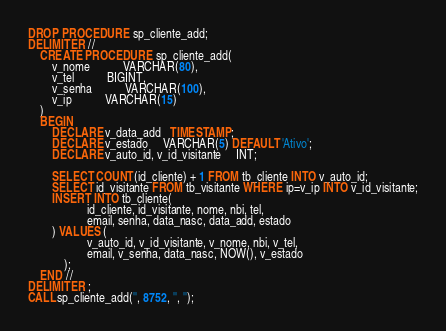<code> <loc_0><loc_0><loc_500><loc_500><_SQL_>DROP PROCEDURE sp_cliente_add;
DELIMITER //
	CREATE PROCEDURE sp_cliente_add(
		v_nome 		   VARCHAR(80),
		v_tel 		   BIGINT,
		v_senha	       VARCHAR(100),
		v_ip 		   VARCHAR(15)
    )
    BEGIN
        DECLARE v_data_add   TIMESTAMP;
		DECLARE v_estado     VARCHAR(5) DEFAULT 'Ativo';
        DECLARE v_auto_id, v_id_visitante	 INT;

        SELECT COUNT(id_cliente) + 1 FROM tb_cliente INTO v_auto_id;
        SELECT id_visitante FROM tb_visitante WHERE ip=v_ip INTO v_id_visitante;
		INSERT INTO tb_cliente(
					id_cliente, id_visitante, nome, nbi, tel, 
					email, senha, data_nasc, data_add, estado
		) VALUES (
					v_auto_id, v_id_visitante, v_nome, nbi, v_tel,
					email, v_senha, data_nasc, NOW(), v_estado
			);			
	END //
DELIMITER ;
CALL sp_cliente_add('', 8752, '', '');</code> 